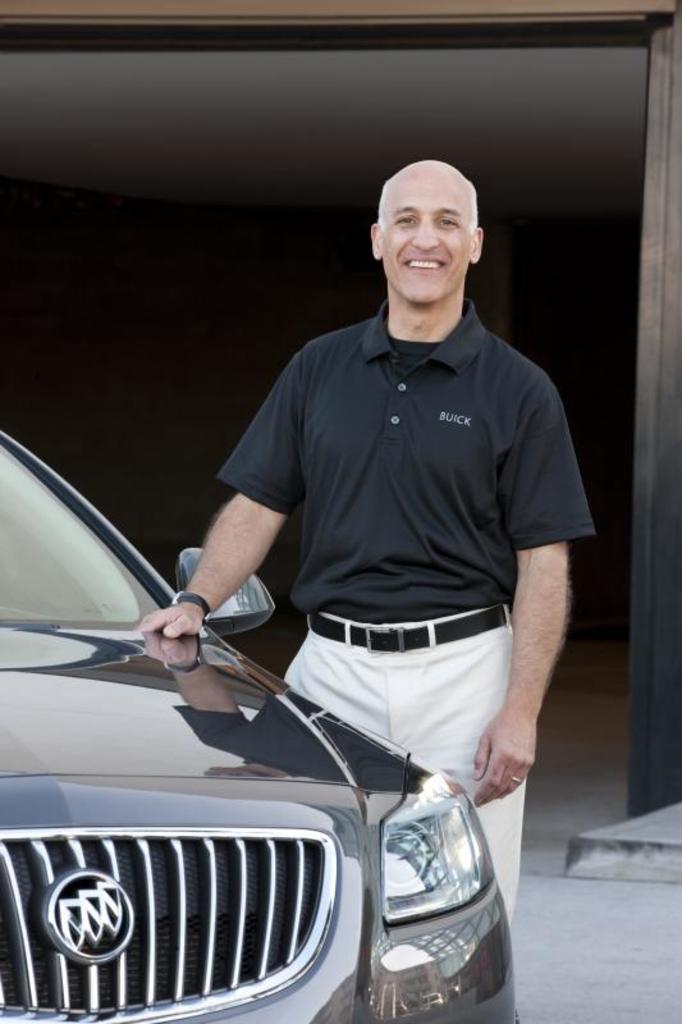Please provide a concise description of this image. There is one man standing and wearing a black color t shirt in the middle of this image, and there is a car on the left side of this image. It is dark in the background. 